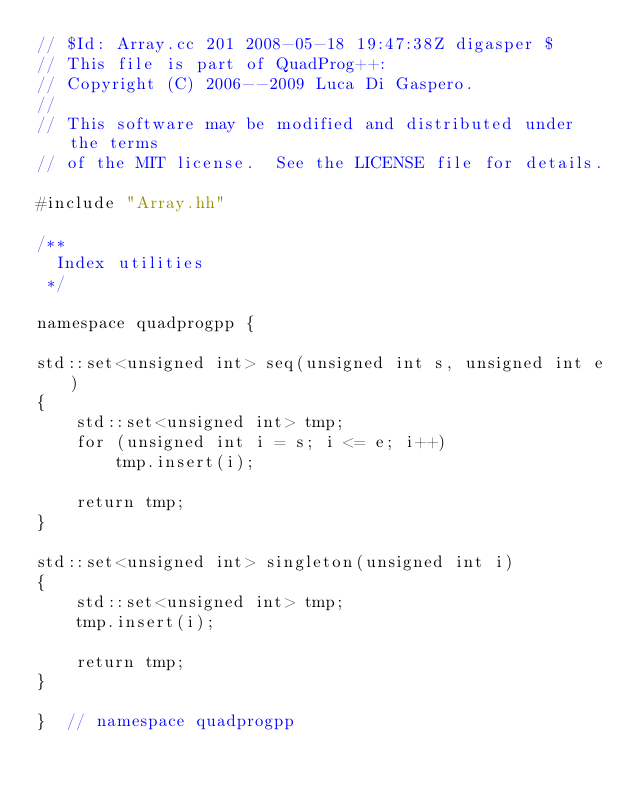Convert code to text. <code><loc_0><loc_0><loc_500><loc_500><_C++_>// $Id: Array.cc 201 2008-05-18 19:47:38Z digasper $
// This file is part of QuadProg++:  
// Copyright (C) 2006--2009 Luca Di Gaspero. 
//
// This software may be modified and distributed under the terms
// of the MIT license.  See the LICENSE file for details.

#include "Array.hh"

/**
  Index utilities
 */

namespace quadprogpp {

std::set<unsigned int> seq(unsigned int s, unsigned int e)
{
	std::set<unsigned int> tmp;
	for (unsigned int i = s; i <= e; i++)
		tmp.insert(i);
	
	return tmp;
}

std::set<unsigned int> singleton(unsigned int i)
{
	std::set<unsigned int> tmp;
	tmp.insert(i);
	
	return tmp;
}

}  // namespace quadprogpp
</code> 